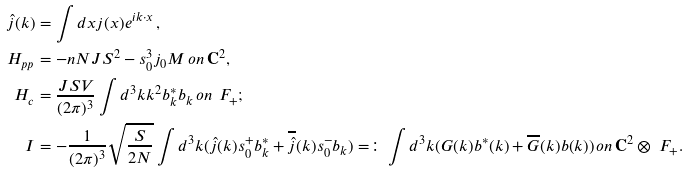<formula> <loc_0><loc_0><loc_500><loc_500>\hat { j } ( k ) & = \int d x j ( x ) e ^ { i k \cdot x } \, , \\ H _ { p p } & = - n N J S ^ { 2 } - s _ { 0 } ^ { 3 } j _ { 0 } M \, o n \, { \mathbf C } ^ { 2 } , \\ H _ { c } & = \frac { J S V } { ( 2 \pi ) ^ { 3 } } \int d ^ { 3 } k k ^ { 2 } b _ { k } ^ { * } b _ { k } \, o n \, \ F _ { + } ; \\ I & = - \frac { 1 } { ( 2 \pi ) ^ { 3 } } \sqrt { \frac { S } { 2 N } } \int d ^ { 3 } k ( \hat { j } ( k ) s _ { 0 } ^ { + } b ^ { * } _ { k } + \overline { \hat { j } } ( k ) s _ { 0 } ^ { - } b _ { k } ) = \colon \int d ^ { 3 } k ( G ( k ) b ^ { * } ( k ) + \overline { G } ( k ) b ( k ) ) \, o n \, { \mathbf C } ^ { 2 } \otimes \ F _ { + } .</formula> 